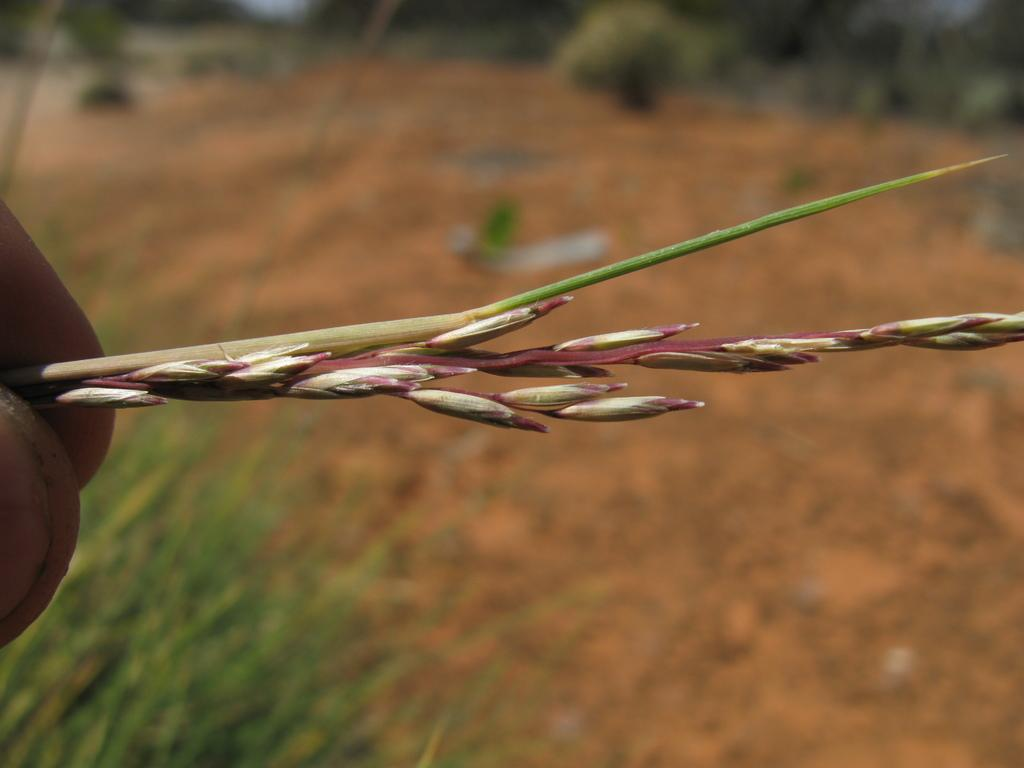What is the person holding in the image? The person's fingers are holding a plant in the image. Can you describe the background of the image? The background of the image is blurred. What type of cap is the person wearing in the image? There is no cap visible in the image; the person's fingers are holding a plant. What type of root can be seen growing from the plant in the image? There is no root visible in the image, as only the person's fingers holding the plant are shown. 